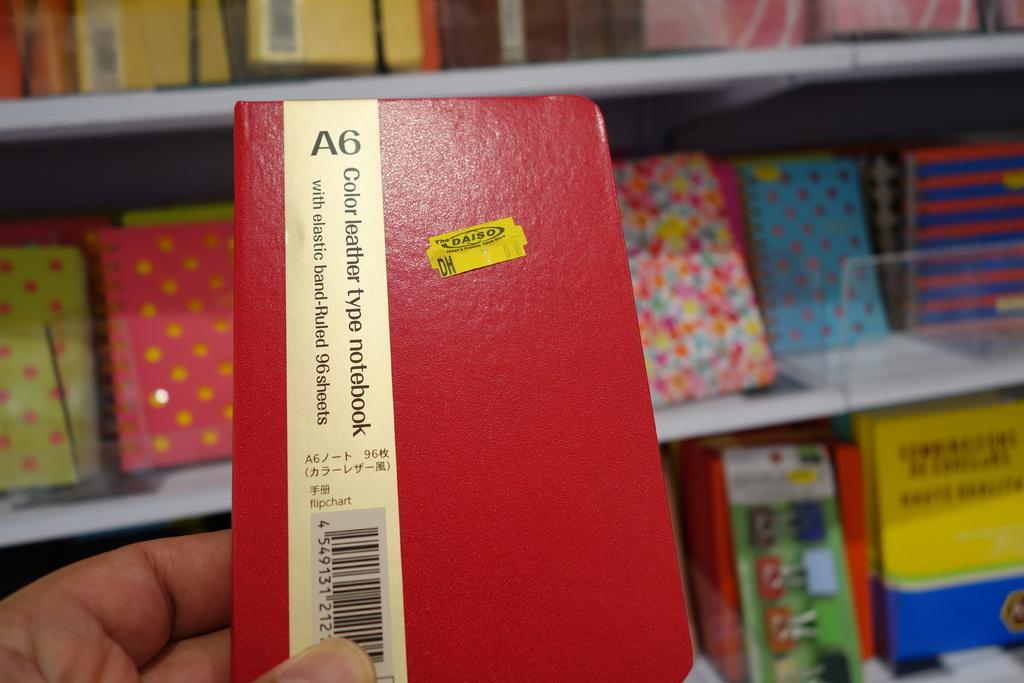<image>
Render a clear and concise summary of the photo. a little book with A6 written at the top of it 